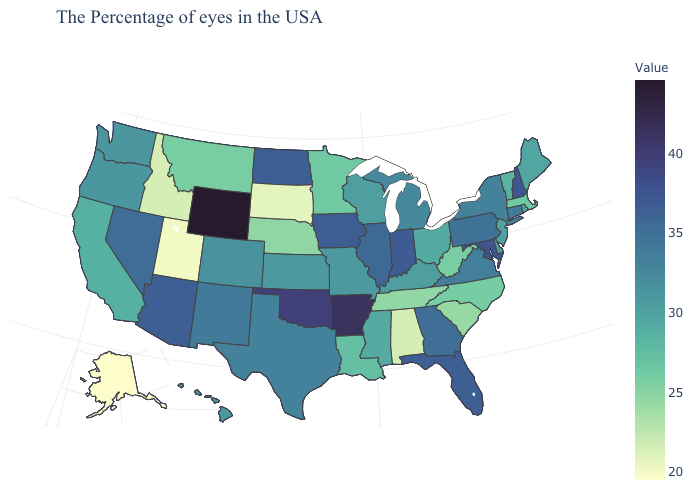Does Alabama have the lowest value in the South?
Give a very brief answer. Yes. Does Alabama have the lowest value in the South?
Concise answer only. Yes. Among the states that border Mississippi , which have the lowest value?
Be succinct. Alabama. Does New Mexico have a higher value than Alabama?
Write a very short answer. Yes. Which states have the highest value in the USA?
Answer briefly. Wyoming. 